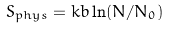<formula> <loc_0><loc_0><loc_500><loc_500>S _ { p h y s } = k b \ln ( N / N _ { 0 } )</formula> 